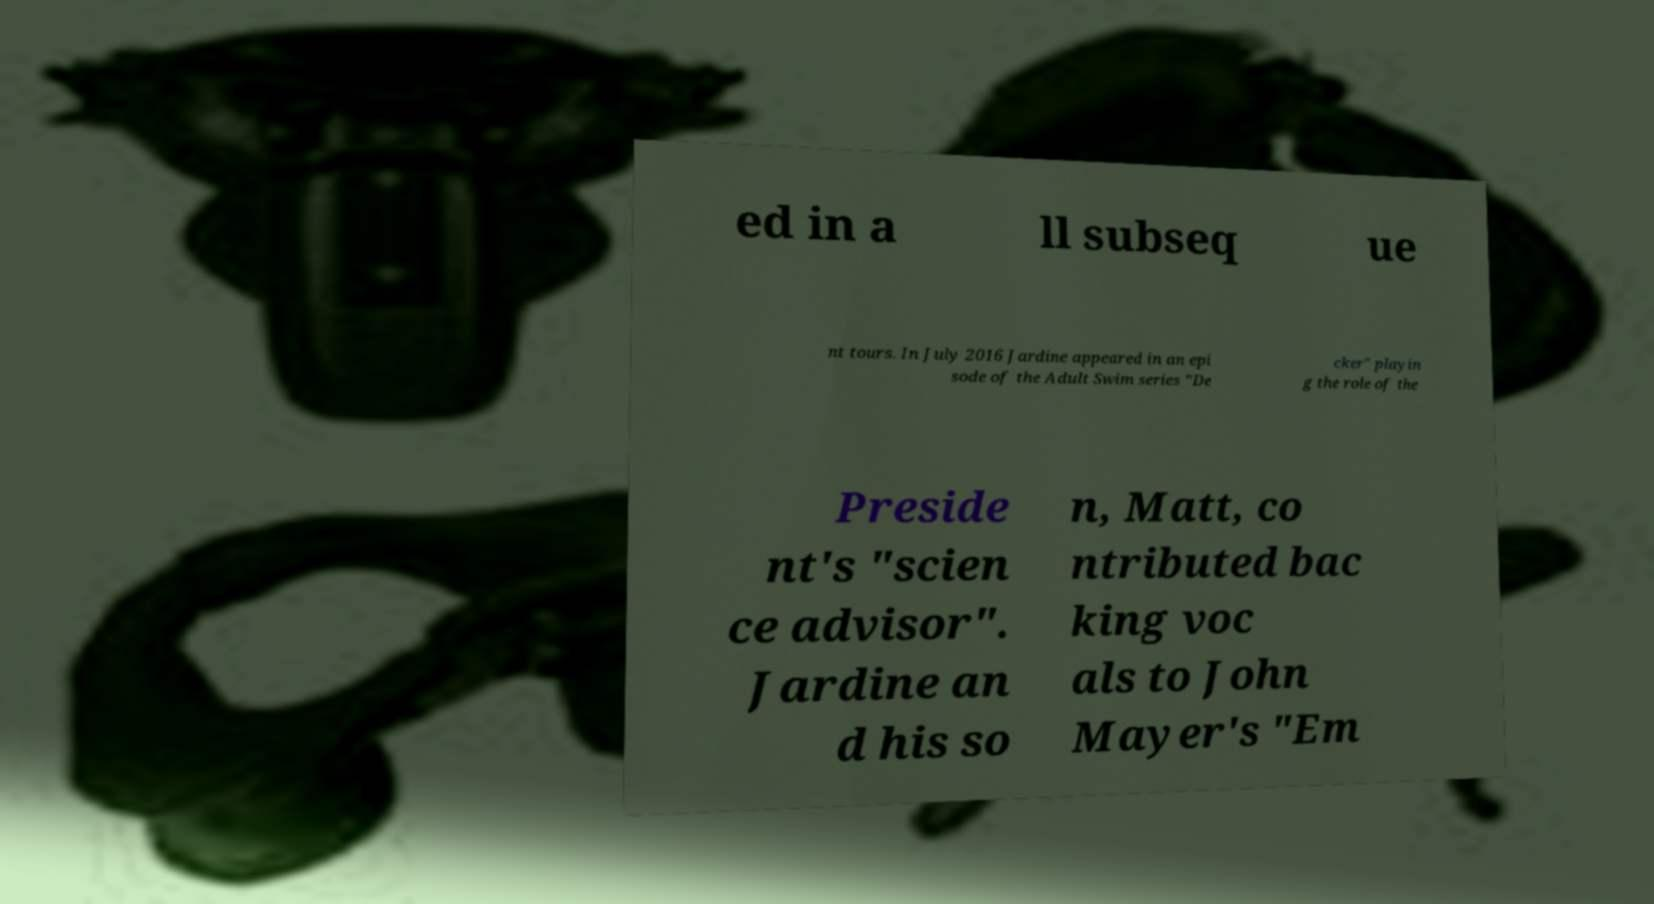Could you extract and type out the text from this image? ed in a ll subseq ue nt tours. In July 2016 Jardine appeared in an epi sode of the Adult Swim series "De cker" playin g the role of the Preside nt's "scien ce advisor". Jardine an d his so n, Matt, co ntributed bac king voc als to John Mayer's "Em 